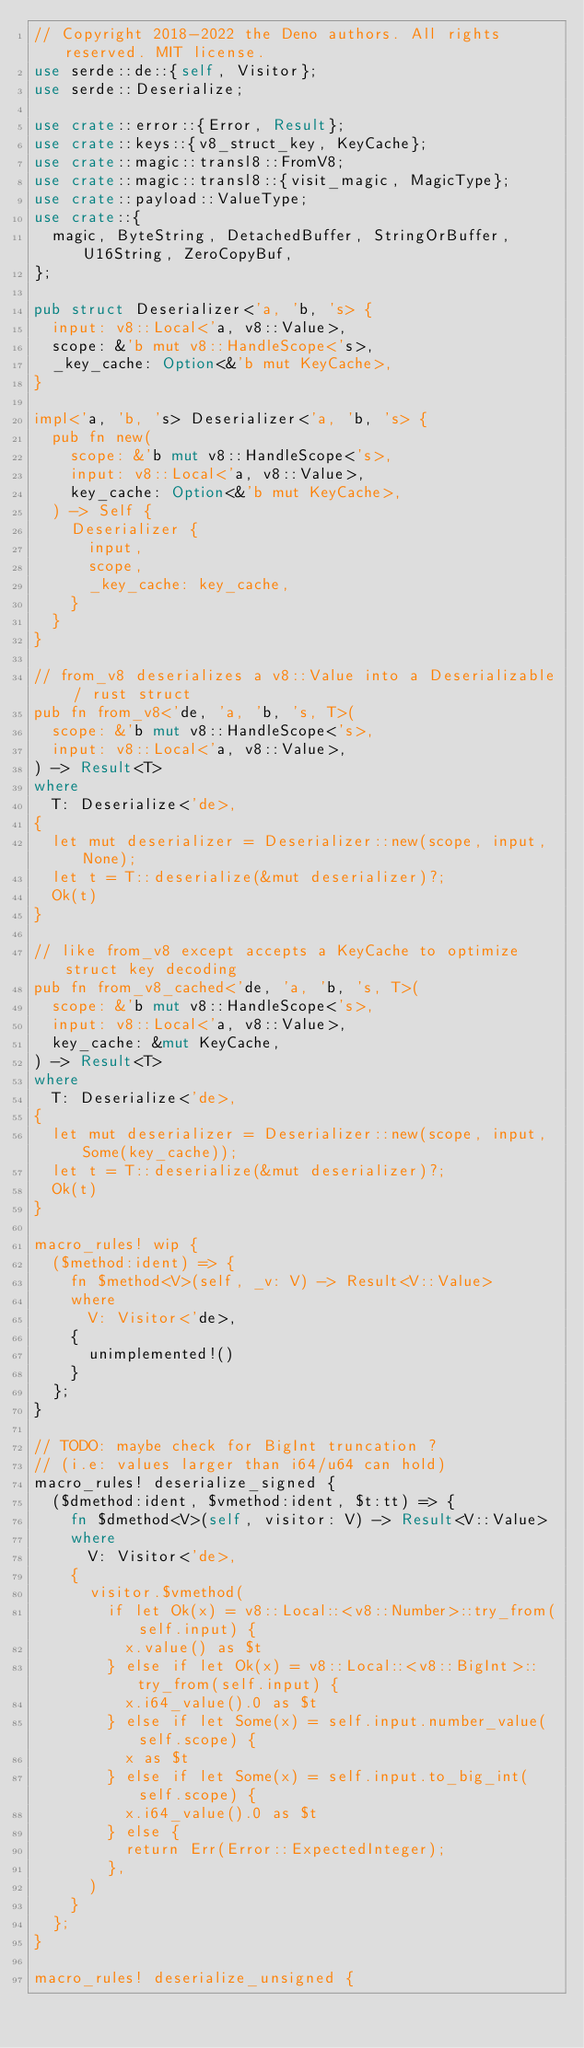<code> <loc_0><loc_0><loc_500><loc_500><_Rust_>// Copyright 2018-2022 the Deno authors. All rights reserved. MIT license.
use serde::de::{self, Visitor};
use serde::Deserialize;

use crate::error::{Error, Result};
use crate::keys::{v8_struct_key, KeyCache};
use crate::magic::transl8::FromV8;
use crate::magic::transl8::{visit_magic, MagicType};
use crate::payload::ValueType;
use crate::{
  magic, ByteString, DetachedBuffer, StringOrBuffer, U16String, ZeroCopyBuf,
};

pub struct Deserializer<'a, 'b, 's> {
  input: v8::Local<'a, v8::Value>,
  scope: &'b mut v8::HandleScope<'s>,
  _key_cache: Option<&'b mut KeyCache>,
}

impl<'a, 'b, 's> Deserializer<'a, 'b, 's> {
  pub fn new(
    scope: &'b mut v8::HandleScope<'s>,
    input: v8::Local<'a, v8::Value>,
    key_cache: Option<&'b mut KeyCache>,
  ) -> Self {
    Deserializer {
      input,
      scope,
      _key_cache: key_cache,
    }
  }
}

// from_v8 deserializes a v8::Value into a Deserializable / rust struct
pub fn from_v8<'de, 'a, 'b, 's, T>(
  scope: &'b mut v8::HandleScope<'s>,
  input: v8::Local<'a, v8::Value>,
) -> Result<T>
where
  T: Deserialize<'de>,
{
  let mut deserializer = Deserializer::new(scope, input, None);
  let t = T::deserialize(&mut deserializer)?;
  Ok(t)
}

// like from_v8 except accepts a KeyCache to optimize struct key decoding
pub fn from_v8_cached<'de, 'a, 'b, 's, T>(
  scope: &'b mut v8::HandleScope<'s>,
  input: v8::Local<'a, v8::Value>,
  key_cache: &mut KeyCache,
) -> Result<T>
where
  T: Deserialize<'de>,
{
  let mut deserializer = Deserializer::new(scope, input, Some(key_cache));
  let t = T::deserialize(&mut deserializer)?;
  Ok(t)
}

macro_rules! wip {
  ($method:ident) => {
    fn $method<V>(self, _v: V) -> Result<V::Value>
    where
      V: Visitor<'de>,
    {
      unimplemented!()
    }
  };
}

// TODO: maybe check for BigInt truncation ?
// (i.e: values larger than i64/u64 can hold)
macro_rules! deserialize_signed {
  ($dmethod:ident, $vmethod:ident, $t:tt) => {
    fn $dmethod<V>(self, visitor: V) -> Result<V::Value>
    where
      V: Visitor<'de>,
    {
      visitor.$vmethod(
        if let Ok(x) = v8::Local::<v8::Number>::try_from(self.input) {
          x.value() as $t
        } else if let Ok(x) = v8::Local::<v8::BigInt>::try_from(self.input) {
          x.i64_value().0 as $t
        } else if let Some(x) = self.input.number_value(self.scope) {
          x as $t
        } else if let Some(x) = self.input.to_big_int(self.scope) {
          x.i64_value().0 as $t
        } else {
          return Err(Error::ExpectedInteger);
        },
      )
    }
  };
}

macro_rules! deserialize_unsigned {</code> 